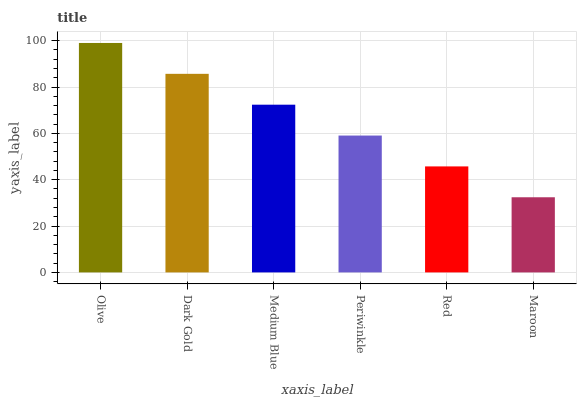Is Maroon the minimum?
Answer yes or no. Yes. Is Olive the maximum?
Answer yes or no. Yes. Is Dark Gold the minimum?
Answer yes or no. No. Is Dark Gold the maximum?
Answer yes or no. No. Is Olive greater than Dark Gold?
Answer yes or no. Yes. Is Dark Gold less than Olive?
Answer yes or no. Yes. Is Dark Gold greater than Olive?
Answer yes or no. No. Is Olive less than Dark Gold?
Answer yes or no. No. Is Medium Blue the high median?
Answer yes or no. Yes. Is Periwinkle the low median?
Answer yes or no. Yes. Is Red the high median?
Answer yes or no. No. Is Dark Gold the low median?
Answer yes or no. No. 